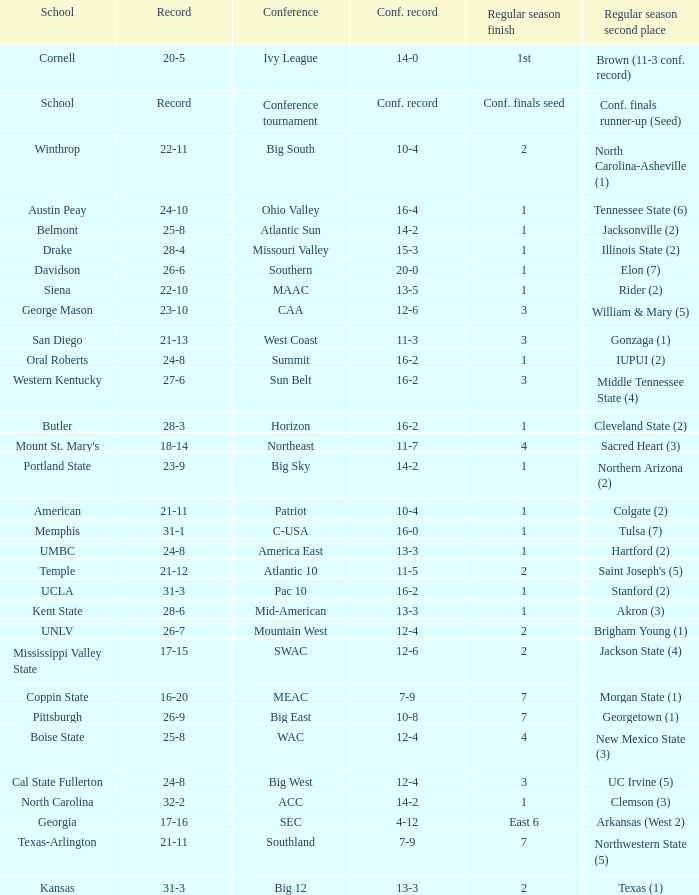Would you be able to parse every entry in this table? {'header': ['School', 'Record', 'Conference', 'Conf. record', 'Regular season finish', 'Regular season second place'], 'rows': [['Cornell', '20-5', 'Ivy League', '14-0', '1st', 'Brown (11-3 conf. record)'], ['School', 'Record', 'Conference tournament', 'Conf. record', 'Conf. finals seed', 'Conf. finals runner-up (Seed)'], ['Winthrop', '22-11', 'Big South', '10-4', '2', 'North Carolina-Asheville (1)'], ['Austin Peay', '24-10', 'Ohio Valley', '16-4', '1', 'Tennessee State (6)'], ['Belmont', '25-8', 'Atlantic Sun', '14-2', '1', 'Jacksonville (2)'], ['Drake', '28-4', 'Missouri Valley', '15-3', '1', 'Illinois State (2)'], ['Davidson', '26-6', 'Southern', '20-0', '1', 'Elon (7)'], ['Siena', '22-10', 'MAAC', '13-5', '1', 'Rider (2)'], ['George Mason', '23-10', 'CAA', '12-6', '3', 'William & Mary (5)'], ['San Diego', '21-13', 'West Coast', '11-3', '3', 'Gonzaga (1)'], ['Oral Roberts', '24-8', 'Summit', '16-2', '1', 'IUPUI (2)'], ['Western Kentucky', '27-6', 'Sun Belt', '16-2', '3', 'Middle Tennessee State (4)'], ['Butler', '28-3', 'Horizon', '16-2', '1', 'Cleveland State (2)'], ["Mount St. Mary's", '18-14', 'Northeast', '11-7', '4', 'Sacred Heart (3)'], ['Portland State', '23-9', 'Big Sky', '14-2', '1', 'Northern Arizona (2)'], ['American', '21-11', 'Patriot', '10-4', '1', 'Colgate (2)'], ['Memphis', '31-1', 'C-USA', '16-0', '1', 'Tulsa (7)'], ['UMBC', '24-8', 'America East', '13-3', '1', 'Hartford (2)'], ['Temple', '21-12', 'Atlantic 10', '11-5', '2', "Saint Joseph's (5)"], ['UCLA', '31-3', 'Pac 10', '16-2', '1', 'Stanford (2)'], ['Kent State', '28-6', 'Mid-American', '13-3', '1', 'Akron (3)'], ['UNLV', '26-7', 'Mountain West', '12-4', '2', 'Brigham Young (1)'], ['Mississippi Valley State', '17-15', 'SWAC', '12-6', '2', 'Jackson State (4)'], ['Coppin State', '16-20', 'MEAC', '7-9', '7', 'Morgan State (1)'], ['Pittsburgh', '26-9', 'Big East', '10-8', '7', 'Georgetown (1)'], ['Boise State', '25-8', 'WAC', '12-4', '4', 'New Mexico State (3)'], ['Cal State Fullerton', '24-8', 'Big West', '12-4', '3', 'UC Irvine (5)'], ['North Carolina', '32-2', 'ACC', '14-2', '1', 'Clemson (3)'], ['Georgia', '17-16', 'SEC', '4-12', 'East 6', 'Arkansas (West 2)'], ['Texas-Arlington', '21-11', 'Southland', '7-9', '7', 'Northwestern State (5)'], ['Kansas', '31-3', 'Big 12', '13-3', '2', 'Texas (1)']]} Which conference is Belmont in? Atlantic Sun. 